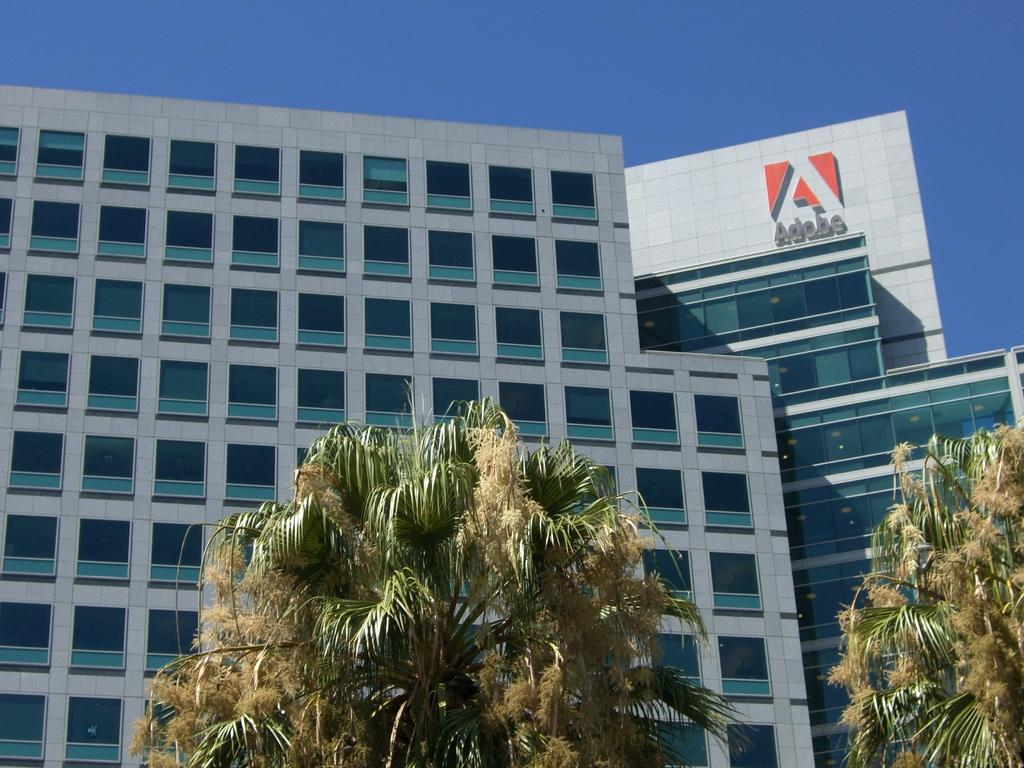What type of vegetation is at the bottom of the image? There are trees at the bottom of the image. What structures can be seen in the background of the image? There are buildings in the background of the image. Can you describe any specific details about the buildings? One of the buildings has text on it. What is visible at the top of the image? The sky is visible at the top of the image. What type of hat is being worn by the tree at the bottom of the image? There is no hat present in the image, as the main subjects are trees and buildings. 